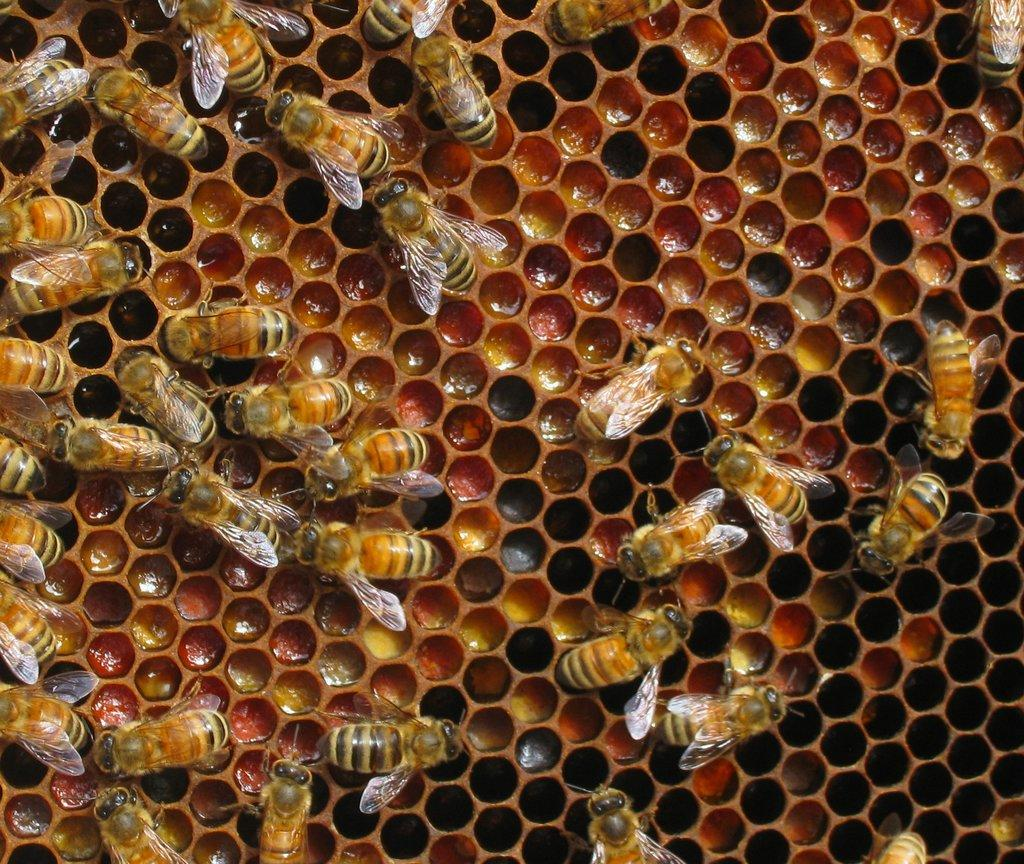What type of insects can be seen in the image? There are honey bees in the image. What are the honey bees doing in the image? The honey bees are on pollen. What can be found in the holes in the image? Honey is visible in the holes. What type of game is being played in the image? There is no game being played in the image; it features honey bees on pollen and honey in holes. What button is being pushed in the image? There is no button present in the image. 